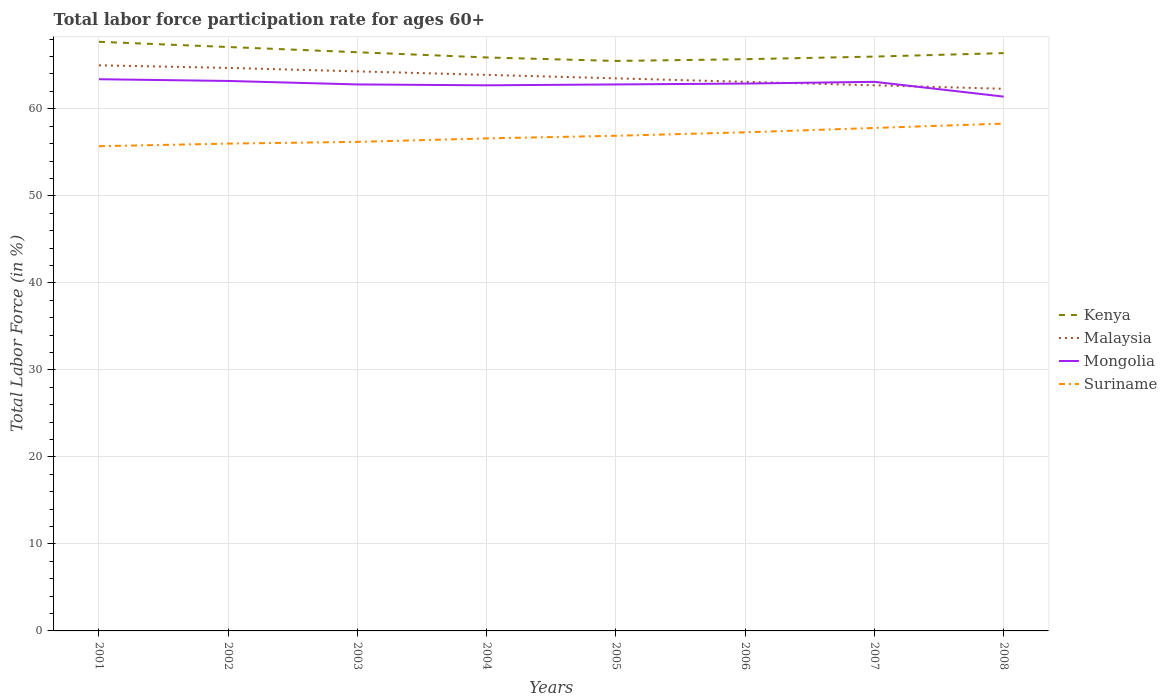Does the line corresponding to Kenya intersect with the line corresponding to Suriname?
Ensure brevity in your answer.  No. Across all years, what is the maximum labor force participation rate in Suriname?
Provide a short and direct response. 55.7. In which year was the labor force participation rate in Malaysia maximum?
Your answer should be very brief. 2008. What is the total labor force participation rate in Mongolia in the graph?
Offer a very short reply. 0.2. What is the difference between the highest and the second highest labor force participation rate in Suriname?
Offer a terse response. 2.6. How many years are there in the graph?
Your answer should be compact. 8. What is the difference between two consecutive major ticks on the Y-axis?
Make the answer very short. 10. Are the values on the major ticks of Y-axis written in scientific E-notation?
Ensure brevity in your answer.  No. Does the graph contain grids?
Your response must be concise. Yes. Where does the legend appear in the graph?
Your answer should be very brief. Center right. What is the title of the graph?
Keep it short and to the point. Total labor force participation rate for ages 60+. What is the Total Labor Force (in %) in Kenya in 2001?
Your response must be concise. 67.7. What is the Total Labor Force (in %) of Malaysia in 2001?
Give a very brief answer. 65. What is the Total Labor Force (in %) of Mongolia in 2001?
Provide a succinct answer. 63.4. What is the Total Labor Force (in %) in Suriname in 2001?
Give a very brief answer. 55.7. What is the Total Labor Force (in %) in Kenya in 2002?
Your response must be concise. 67.1. What is the Total Labor Force (in %) in Malaysia in 2002?
Offer a very short reply. 64.7. What is the Total Labor Force (in %) of Mongolia in 2002?
Keep it short and to the point. 63.2. What is the Total Labor Force (in %) of Suriname in 2002?
Your response must be concise. 56. What is the Total Labor Force (in %) of Kenya in 2003?
Your answer should be compact. 66.5. What is the Total Labor Force (in %) of Malaysia in 2003?
Make the answer very short. 64.3. What is the Total Labor Force (in %) in Mongolia in 2003?
Offer a very short reply. 62.8. What is the Total Labor Force (in %) in Suriname in 2003?
Your answer should be very brief. 56.2. What is the Total Labor Force (in %) of Kenya in 2004?
Give a very brief answer. 65.9. What is the Total Labor Force (in %) of Malaysia in 2004?
Your response must be concise. 63.9. What is the Total Labor Force (in %) in Mongolia in 2004?
Your answer should be very brief. 62.7. What is the Total Labor Force (in %) of Suriname in 2004?
Keep it short and to the point. 56.6. What is the Total Labor Force (in %) in Kenya in 2005?
Your answer should be compact. 65.5. What is the Total Labor Force (in %) in Malaysia in 2005?
Your answer should be very brief. 63.5. What is the Total Labor Force (in %) in Mongolia in 2005?
Ensure brevity in your answer.  62.8. What is the Total Labor Force (in %) in Suriname in 2005?
Provide a succinct answer. 56.9. What is the Total Labor Force (in %) in Kenya in 2006?
Give a very brief answer. 65.7. What is the Total Labor Force (in %) in Malaysia in 2006?
Your answer should be compact. 63.1. What is the Total Labor Force (in %) of Mongolia in 2006?
Your response must be concise. 62.9. What is the Total Labor Force (in %) of Suriname in 2006?
Offer a very short reply. 57.3. What is the Total Labor Force (in %) of Malaysia in 2007?
Your answer should be very brief. 62.7. What is the Total Labor Force (in %) in Mongolia in 2007?
Your answer should be compact. 63.1. What is the Total Labor Force (in %) in Suriname in 2007?
Offer a terse response. 57.8. What is the Total Labor Force (in %) of Kenya in 2008?
Ensure brevity in your answer.  66.4. What is the Total Labor Force (in %) in Malaysia in 2008?
Your answer should be compact. 62.3. What is the Total Labor Force (in %) of Mongolia in 2008?
Offer a terse response. 61.4. What is the Total Labor Force (in %) in Suriname in 2008?
Provide a short and direct response. 58.3. Across all years, what is the maximum Total Labor Force (in %) in Kenya?
Keep it short and to the point. 67.7. Across all years, what is the maximum Total Labor Force (in %) in Malaysia?
Your answer should be very brief. 65. Across all years, what is the maximum Total Labor Force (in %) of Mongolia?
Ensure brevity in your answer.  63.4. Across all years, what is the maximum Total Labor Force (in %) of Suriname?
Offer a very short reply. 58.3. Across all years, what is the minimum Total Labor Force (in %) of Kenya?
Offer a very short reply. 65.5. Across all years, what is the minimum Total Labor Force (in %) in Malaysia?
Provide a short and direct response. 62.3. Across all years, what is the minimum Total Labor Force (in %) of Mongolia?
Keep it short and to the point. 61.4. Across all years, what is the minimum Total Labor Force (in %) in Suriname?
Offer a terse response. 55.7. What is the total Total Labor Force (in %) of Kenya in the graph?
Offer a very short reply. 530.8. What is the total Total Labor Force (in %) of Malaysia in the graph?
Keep it short and to the point. 509.5. What is the total Total Labor Force (in %) of Mongolia in the graph?
Provide a succinct answer. 502.3. What is the total Total Labor Force (in %) of Suriname in the graph?
Give a very brief answer. 454.8. What is the difference between the Total Labor Force (in %) of Malaysia in 2001 and that in 2002?
Your answer should be very brief. 0.3. What is the difference between the Total Labor Force (in %) of Mongolia in 2001 and that in 2002?
Give a very brief answer. 0.2. What is the difference between the Total Labor Force (in %) of Suriname in 2001 and that in 2002?
Give a very brief answer. -0.3. What is the difference between the Total Labor Force (in %) of Kenya in 2001 and that in 2003?
Give a very brief answer. 1.2. What is the difference between the Total Labor Force (in %) in Mongolia in 2001 and that in 2003?
Provide a succinct answer. 0.6. What is the difference between the Total Labor Force (in %) in Malaysia in 2001 and that in 2004?
Keep it short and to the point. 1.1. What is the difference between the Total Labor Force (in %) in Suriname in 2001 and that in 2004?
Offer a very short reply. -0.9. What is the difference between the Total Labor Force (in %) in Kenya in 2001 and that in 2005?
Ensure brevity in your answer.  2.2. What is the difference between the Total Labor Force (in %) in Suriname in 2001 and that in 2005?
Offer a terse response. -1.2. What is the difference between the Total Labor Force (in %) in Kenya in 2001 and that in 2006?
Provide a short and direct response. 2. What is the difference between the Total Labor Force (in %) of Mongolia in 2001 and that in 2006?
Offer a very short reply. 0.5. What is the difference between the Total Labor Force (in %) of Suriname in 2001 and that in 2006?
Keep it short and to the point. -1.6. What is the difference between the Total Labor Force (in %) in Suriname in 2001 and that in 2007?
Give a very brief answer. -2.1. What is the difference between the Total Labor Force (in %) in Malaysia in 2001 and that in 2008?
Provide a succinct answer. 2.7. What is the difference between the Total Labor Force (in %) of Mongolia in 2001 and that in 2008?
Keep it short and to the point. 2. What is the difference between the Total Labor Force (in %) in Suriname in 2001 and that in 2008?
Give a very brief answer. -2.6. What is the difference between the Total Labor Force (in %) in Kenya in 2002 and that in 2003?
Provide a short and direct response. 0.6. What is the difference between the Total Labor Force (in %) in Mongolia in 2002 and that in 2003?
Provide a succinct answer. 0.4. What is the difference between the Total Labor Force (in %) of Malaysia in 2002 and that in 2004?
Your answer should be very brief. 0.8. What is the difference between the Total Labor Force (in %) in Suriname in 2002 and that in 2004?
Ensure brevity in your answer.  -0.6. What is the difference between the Total Labor Force (in %) of Kenya in 2002 and that in 2005?
Provide a succinct answer. 1.6. What is the difference between the Total Labor Force (in %) of Malaysia in 2002 and that in 2005?
Make the answer very short. 1.2. What is the difference between the Total Labor Force (in %) in Mongolia in 2002 and that in 2005?
Give a very brief answer. 0.4. What is the difference between the Total Labor Force (in %) of Suriname in 2002 and that in 2005?
Make the answer very short. -0.9. What is the difference between the Total Labor Force (in %) in Kenya in 2002 and that in 2006?
Your response must be concise. 1.4. What is the difference between the Total Labor Force (in %) of Malaysia in 2002 and that in 2007?
Give a very brief answer. 2. What is the difference between the Total Labor Force (in %) of Mongolia in 2002 and that in 2007?
Offer a terse response. 0.1. What is the difference between the Total Labor Force (in %) in Malaysia in 2002 and that in 2008?
Provide a short and direct response. 2.4. What is the difference between the Total Labor Force (in %) of Mongolia in 2002 and that in 2008?
Give a very brief answer. 1.8. What is the difference between the Total Labor Force (in %) of Malaysia in 2003 and that in 2004?
Make the answer very short. 0.4. What is the difference between the Total Labor Force (in %) of Mongolia in 2003 and that in 2004?
Your answer should be very brief. 0.1. What is the difference between the Total Labor Force (in %) in Kenya in 2003 and that in 2005?
Your answer should be compact. 1. What is the difference between the Total Labor Force (in %) in Suriname in 2003 and that in 2005?
Make the answer very short. -0.7. What is the difference between the Total Labor Force (in %) of Kenya in 2003 and that in 2006?
Keep it short and to the point. 0.8. What is the difference between the Total Labor Force (in %) of Malaysia in 2003 and that in 2006?
Your response must be concise. 1.2. What is the difference between the Total Labor Force (in %) of Mongolia in 2003 and that in 2006?
Offer a very short reply. -0.1. What is the difference between the Total Labor Force (in %) in Kenya in 2003 and that in 2007?
Provide a short and direct response. 0.5. What is the difference between the Total Labor Force (in %) in Malaysia in 2003 and that in 2007?
Your answer should be very brief. 1.6. What is the difference between the Total Labor Force (in %) in Mongolia in 2003 and that in 2007?
Offer a very short reply. -0.3. What is the difference between the Total Labor Force (in %) in Suriname in 2003 and that in 2007?
Your response must be concise. -1.6. What is the difference between the Total Labor Force (in %) in Kenya in 2003 and that in 2008?
Provide a succinct answer. 0.1. What is the difference between the Total Labor Force (in %) in Suriname in 2004 and that in 2005?
Make the answer very short. -0.3. What is the difference between the Total Labor Force (in %) of Kenya in 2004 and that in 2006?
Offer a terse response. 0.2. What is the difference between the Total Labor Force (in %) in Kenya in 2004 and that in 2007?
Ensure brevity in your answer.  -0.1. What is the difference between the Total Labor Force (in %) in Malaysia in 2004 and that in 2007?
Provide a short and direct response. 1.2. What is the difference between the Total Labor Force (in %) in Suriname in 2004 and that in 2007?
Ensure brevity in your answer.  -1.2. What is the difference between the Total Labor Force (in %) in Kenya in 2004 and that in 2008?
Your answer should be compact. -0.5. What is the difference between the Total Labor Force (in %) in Mongolia in 2004 and that in 2008?
Your answer should be compact. 1.3. What is the difference between the Total Labor Force (in %) in Suriname in 2004 and that in 2008?
Ensure brevity in your answer.  -1.7. What is the difference between the Total Labor Force (in %) of Kenya in 2005 and that in 2006?
Keep it short and to the point. -0.2. What is the difference between the Total Labor Force (in %) of Mongolia in 2005 and that in 2006?
Keep it short and to the point. -0.1. What is the difference between the Total Labor Force (in %) in Malaysia in 2005 and that in 2007?
Keep it short and to the point. 0.8. What is the difference between the Total Labor Force (in %) in Mongolia in 2005 and that in 2007?
Your answer should be very brief. -0.3. What is the difference between the Total Labor Force (in %) in Suriname in 2005 and that in 2007?
Give a very brief answer. -0.9. What is the difference between the Total Labor Force (in %) of Malaysia in 2006 and that in 2007?
Provide a succinct answer. 0.4. What is the difference between the Total Labor Force (in %) of Mongolia in 2006 and that in 2007?
Provide a short and direct response. -0.2. What is the difference between the Total Labor Force (in %) in Suriname in 2006 and that in 2007?
Your answer should be compact. -0.5. What is the difference between the Total Labor Force (in %) of Malaysia in 2006 and that in 2008?
Your response must be concise. 0.8. What is the difference between the Total Labor Force (in %) of Mongolia in 2006 and that in 2008?
Make the answer very short. 1.5. What is the difference between the Total Labor Force (in %) of Kenya in 2007 and that in 2008?
Your answer should be compact. -0.4. What is the difference between the Total Labor Force (in %) in Mongolia in 2007 and that in 2008?
Ensure brevity in your answer.  1.7. What is the difference between the Total Labor Force (in %) of Kenya in 2001 and the Total Labor Force (in %) of Malaysia in 2002?
Offer a terse response. 3. What is the difference between the Total Labor Force (in %) in Malaysia in 2001 and the Total Labor Force (in %) in Mongolia in 2002?
Your response must be concise. 1.8. What is the difference between the Total Labor Force (in %) in Mongolia in 2001 and the Total Labor Force (in %) in Suriname in 2002?
Offer a terse response. 7.4. What is the difference between the Total Labor Force (in %) of Kenya in 2001 and the Total Labor Force (in %) of Suriname in 2003?
Ensure brevity in your answer.  11.5. What is the difference between the Total Labor Force (in %) in Malaysia in 2001 and the Total Labor Force (in %) in Suriname in 2003?
Provide a short and direct response. 8.8. What is the difference between the Total Labor Force (in %) in Mongolia in 2001 and the Total Labor Force (in %) in Suriname in 2003?
Offer a very short reply. 7.2. What is the difference between the Total Labor Force (in %) of Kenya in 2001 and the Total Labor Force (in %) of Malaysia in 2004?
Keep it short and to the point. 3.8. What is the difference between the Total Labor Force (in %) of Malaysia in 2001 and the Total Labor Force (in %) of Mongolia in 2004?
Make the answer very short. 2.3. What is the difference between the Total Labor Force (in %) in Malaysia in 2001 and the Total Labor Force (in %) in Suriname in 2004?
Provide a short and direct response. 8.4. What is the difference between the Total Labor Force (in %) in Kenya in 2001 and the Total Labor Force (in %) in Malaysia in 2005?
Provide a succinct answer. 4.2. What is the difference between the Total Labor Force (in %) of Kenya in 2001 and the Total Labor Force (in %) of Malaysia in 2006?
Keep it short and to the point. 4.6. What is the difference between the Total Labor Force (in %) in Kenya in 2001 and the Total Labor Force (in %) in Mongolia in 2006?
Give a very brief answer. 4.8. What is the difference between the Total Labor Force (in %) of Malaysia in 2001 and the Total Labor Force (in %) of Mongolia in 2006?
Provide a succinct answer. 2.1. What is the difference between the Total Labor Force (in %) in Malaysia in 2001 and the Total Labor Force (in %) in Suriname in 2006?
Provide a short and direct response. 7.7. What is the difference between the Total Labor Force (in %) in Kenya in 2001 and the Total Labor Force (in %) in Malaysia in 2007?
Provide a succinct answer. 5. What is the difference between the Total Labor Force (in %) in Mongolia in 2001 and the Total Labor Force (in %) in Suriname in 2007?
Keep it short and to the point. 5.6. What is the difference between the Total Labor Force (in %) of Kenya in 2001 and the Total Labor Force (in %) of Malaysia in 2008?
Make the answer very short. 5.4. What is the difference between the Total Labor Force (in %) in Kenya in 2001 and the Total Labor Force (in %) in Mongolia in 2008?
Offer a very short reply. 6.3. What is the difference between the Total Labor Force (in %) of Malaysia in 2001 and the Total Labor Force (in %) of Suriname in 2008?
Give a very brief answer. 6.7. What is the difference between the Total Labor Force (in %) of Kenya in 2002 and the Total Labor Force (in %) of Malaysia in 2003?
Provide a short and direct response. 2.8. What is the difference between the Total Labor Force (in %) in Kenya in 2002 and the Total Labor Force (in %) in Mongolia in 2003?
Provide a short and direct response. 4.3. What is the difference between the Total Labor Force (in %) in Kenya in 2002 and the Total Labor Force (in %) in Suriname in 2003?
Provide a succinct answer. 10.9. What is the difference between the Total Labor Force (in %) of Mongolia in 2002 and the Total Labor Force (in %) of Suriname in 2003?
Offer a very short reply. 7. What is the difference between the Total Labor Force (in %) of Kenya in 2002 and the Total Labor Force (in %) of Malaysia in 2004?
Your response must be concise. 3.2. What is the difference between the Total Labor Force (in %) of Kenya in 2002 and the Total Labor Force (in %) of Mongolia in 2004?
Offer a very short reply. 4.4. What is the difference between the Total Labor Force (in %) in Malaysia in 2002 and the Total Labor Force (in %) in Suriname in 2004?
Make the answer very short. 8.1. What is the difference between the Total Labor Force (in %) of Kenya in 2002 and the Total Labor Force (in %) of Suriname in 2005?
Provide a succinct answer. 10.2. What is the difference between the Total Labor Force (in %) in Malaysia in 2002 and the Total Labor Force (in %) in Mongolia in 2005?
Ensure brevity in your answer.  1.9. What is the difference between the Total Labor Force (in %) in Malaysia in 2002 and the Total Labor Force (in %) in Suriname in 2005?
Give a very brief answer. 7.8. What is the difference between the Total Labor Force (in %) in Kenya in 2002 and the Total Labor Force (in %) in Malaysia in 2006?
Your answer should be compact. 4. What is the difference between the Total Labor Force (in %) in Kenya in 2002 and the Total Labor Force (in %) in Suriname in 2006?
Provide a succinct answer. 9.8. What is the difference between the Total Labor Force (in %) of Malaysia in 2002 and the Total Labor Force (in %) of Suriname in 2006?
Offer a terse response. 7.4. What is the difference between the Total Labor Force (in %) of Kenya in 2002 and the Total Labor Force (in %) of Malaysia in 2007?
Make the answer very short. 4.4. What is the difference between the Total Labor Force (in %) of Kenya in 2002 and the Total Labor Force (in %) of Mongolia in 2008?
Give a very brief answer. 5.7. What is the difference between the Total Labor Force (in %) in Kenya in 2002 and the Total Labor Force (in %) in Suriname in 2008?
Give a very brief answer. 8.8. What is the difference between the Total Labor Force (in %) of Malaysia in 2002 and the Total Labor Force (in %) of Suriname in 2008?
Your answer should be compact. 6.4. What is the difference between the Total Labor Force (in %) in Kenya in 2003 and the Total Labor Force (in %) in Mongolia in 2005?
Give a very brief answer. 3.7. What is the difference between the Total Labor Force (in %) in Malaysia in 2003 and the Total Labor Force (in %) in Suriname in 2005?
Offer a terse response. 7.4. What is the difference between the Total Labor Force (in %) in Mongolia in 2003 and the Total Labor Force (in %) in Suriname in 2005?
Your response must be concise. 5.9. What is the difference between the Total Labor Force (in %) of Kenya in 2003 and the Total Labor Force (in %) of Malaysia in 2006?
Your answer should be compact. 3.4. What is the difference between the Total Labor Force (in %) of Malaysia in 2003 and the Total Labor Force (in %) of Mongolia in 2007?
Offer a terse response. 1.2. What is the difference between the Total Labor Force (in %) of Mongolia in 2003 and the Total Labor Force (in %) of Suriname in 2007?
Offer a very short reply. 5. What is the difference between the Total Labor Force (in %) of Kenya in 2003 and the Total Labor Force (in %) of Malaysia in 2008?
Make the answer very short. 4.2. What is the difference between the Total Labor Force (in %) in Malaysia in 2003 and the Total Labor Force (in %) in Suriname in 2008?
Ensure brevity in your answer.  6. What is the difference between the Total Labor Force (in %) of Mongolia in 2003 and the Total Labor Force (in %) of Suriname in 2008?
Provide a short and direct response. 4.5. What is the difference between the Total Labor Force (in %) in Kenya in 2004 and the Total Labor Force (in %) in Malaysia in 2005?
Your answer should be compact. 2.4. What is the difference between the Total Labor Force (in %) in Kenya in 2004 and the Total Labor Force (in %) in Suriname in 2005?
Ensure brevity in your answer.  9. What is the difference between the Total Labor Force (in %) in Malaysia in 2004 and the Total Labor Force (in %) in Mongolia in 2005?
Your answer should be very brief. 1.1. What is the difference between the Total Labor Force (in %) in Mongolia in 2004 and the Total Labor Force (in %) in Suriname in 2005?
Keep it short and to the point. 5.8. What is the difference between the Total Labor Force (in %) in Kenya in 2004 and the Total Labor Force (in %) in Mongolia in 2006?
Offer a terse response. 3. What is the difference between the Total Labor Force (in %) in Mongolia in 2004 and the Total Labor Force (in %) in Suriname in 2006?
Provide a succinct answer. 5.4. What is the difference between the Total Labor Force (in %) in Kenya in 2004 and the Total Labor Force (in %) in Suriname in 2007?
Provide a short and direct response. 8.1. What is the difference between the Total Labor Force (in %) of Kenya in 2004 and the Total Labor Force (in %) of Mongolia in 2008?
Your response must be concise. 4.5. What is the difference between the Total Labor Force (in %) of Kenya in 2004 and the Total Labor Force (in %) of Suriname in 2008?
Your response must be concise. 7.6. What is the difference between the Total Labor Force (in %) in Malaysia in 2004 and the Total Labor Force (in %) in Mongolia in 2008?
Offer a very short reply. 2.5. What is the difference between the Total Labor Force (in %) in Kenya in 2005 and the Total Labor Force (in %) in Malaysia in 2006?
Ensure brevity in your answer.  2.4. What is the difference between the Total Labor Force (in %) in Kenya in 2005 and the Total Labor Force (in %) in Suriname in 2006?
Offer a very short reply. 8.2. What is the difference between the Total Labor Force (in %) of Malaysia in 2005 and the Total Labor Force (in %) of Suriname in 2006?
Provide a short and direct response. 6.2. What is the difference between the Total Labor Force (in %) in Kenya in 2005 and the Total Labor Force (in %) in Malaysia in 2007?
Your answer should be compact. 2.8. What is the difference between the Total Labor Force (in %) of Mongolia in 2005 and the Total Labor Force (in %) of Suriname in 2007?
Your response must be concise. 5. What is the difference between the Total Labor Force (in %) of Malaysia in 2005 and the Total Labor Force (in %) of Suriname in 2008?
Your answer should be compact. 5.2. What is the difference between the Total Labor Force (in %) in Kenya in 2006 and the Total Labor Force (in %) in Suriname in 2007?
Your response must be concise. 7.9. What is the difference between the Total Labor Force (in %) of Mongolia in 2006 and the Total Labor Force (in %) of Suriname in 2007?
Make the answer very short. 5.1. What is the difference between the Total Labor Force (in %) in Malaysia in 2006 and the Total Labor Force (in %) in Suriname in 2008?
Keep it short and to the point. 4.8. What is the difference between the Total Labor Force (in %) of Kenya in 2007 and the Total Labor Force (in %) of Mongolia in 2008?
Your answer should be compact. 4.6. What is the difference between the Total Labor Force (in %) in Kenya in 2007 and the Total Labor Force (in %) in Suriname in 2008?
Provide a succinct answer. 7.7. What is the difference between the Total Labor Force (in %) in Malaysia in 2007 and the Total Labor Force (in %) in Mongolia in 2008?
Your answer should be compact. 1.3. What is the difference between the Total Labor Force (in %) of Malaysia in 2007 and the Total Labor Force (in %) of Suriname in 2008?
Provide a succinct answer. 4.4. What is the average Total Labor Force (in %) in Kenya per year?
Offer a very short reply. 66.35. What is the average Total Labor Force (in %) in Malaysia per year?
Your answer should be compact. 63.69. What is the average Total Labor Force (in %) in Mongolia per year?
Ensure brevity in your answer.  62.79. What is the average Total Labor Force (in %) of Suriname per year?
Offer a terse response. 56.85. In the year 2001, what is the difference between the Total Labor Force (in %) in Kenya and Total Labor Force (in %) in Malaysia?
Ensure brevity in your answer.  2.7. In the year 2001, what is the difference between the Total Labor Force (in %) in Kenya and Total Labor Force (in %) in Mongolia?
Make the answer very short. 4.3. In the year 2001, what is the difference between the Total Labor Force (in %) of Mongolia and Total Labor Force (in %) of Suriname?
Keep it short and to the point. 7.7. In the year 2002, what is the difference between the Total Labor Force (in %) of Kenya and Total Labor Force (in %) of Malaysia?
Your response must be concise. 2.4. In the year 2002, what is the difference between the Total Labor Force (in %) in Kenya and Total Labor Force (in %) in Suriname?
Your response must be concise. 11.1. In the year 2003, what is the difference between the Total Labor Force (in %) of Kenya and Total Labor Force (in %) of Malaysia?
Keep it short and to the point. 2.2. In the year 2003, what is the difference between the Total Labor Force (in %) of Kenya and Total Labor Force (in %) of Mongolia?
Keep it short and to the point. 3.7. In the year 2003, what is the difference between the Total Labor Force (in %) in Malaysia and Total Labor Force (in %) in Mongolia?
Offer a very short reply. 1.5. In the year 2003, what is the difference between the Total Labor Force (in %) of Mongolia and Total Labor Force (in %) of Suriname?
Offer a very short reply. 6.6. In the year 2004, what is the difference between the Total Labor Force (in %) of Malaysia and Total Labor Force (in %) of Suriname?
Offer a very short reply. 7.3. In the year 2004, what is the difference between the Total Labor Force (in %) of Mongolia and Total Labor Force (in %) of Suriname?
Make the answer very short. 6.1. In the year 2005, what is the difference between the Total Labor Force (in %) in Kenya and Total Labor Force (in %) in Malaysia?
Give a very brief answer. 2. In the year 2005, what is the difference between the Total Labor Force (in %) in Kenya and Total Labor Force (in %) in Mongolia?
Provide a succinct answer. 2.7. In the year 2006, what is the difference between the Total Labor Force (in %) of Malaysia and Total Labor Force (in %) of Suriname?
Provide a short and direct response. 5.8. In the year 2006, what is the difference between the Total Labor Force (in %) in Mongolia and Total Labor Force (in %) in Suriname?
Offer a terse response. 5.6. In the year 2007, what is the difference between the Total Labor Force (in %) of Kenya and Total Labor Force (in %) of Malaysia?
Offer a very short reply. 3.3. In the year 2008, what is the difference between the Total Labor Force (in %) in Kenya and Total Labor Force (in %) in Malaysia?
Your response must be concise. 4.1. In the year 2008, what is the difference between the Total Labor Force (in %) in Malaysia and Total Labor Force (in %) in Suriname?
Your response must be concise. 4. In the year 2008, what is the difference between the Total Labor Force (in %) in Mongolia and Total Labor Force (in %) in Suriname?
Your answer should be very brief. 3.1. What is the ratio of the Total Labor Force (in %) in Kenya in 2001 to that in 2002?
Your answer should be compact. 1.01. What is the ratio of the Total Labor Force (in %) in Malaysia in 2001 to that in 2002?
Provide a short and direct response. 1. What is the ratio of the Total Labor Force (in %) of Kenya in 2001 to that in 2003?
Make the answer very short. 1.02. What is the ratio of the Total Labor Force (in %) in Malaysia in 2001 to that in 2003?
Provide a succinct answer. 1.01. What is the ratio of the Total Labor Force (in %) of Mongolia in 2001 to that in 2003?
Provide a succinct answer. 1.01. What is the ratio of the Total Labor Force (in %) of Suriname in 2001 to that in 2003?
Your answer should be very brief. 0.99. What is the ratio of the Total Labor Force (in %) of Kenya in 2001 to that in 2004?
Offer a terse response. 1.03. What is the ratio of the Total Labor Force (in %) in Malaysia in 2001 to that in 2004?
Ensure brevity in your answer.  1.02. What is the ratio of the Total Labor Force (in %) in Mongolia in 2001 to that in 2004?
Your answer should be very brief. 1.01. What is the ratio of the Total Labor Force (in %) in Suriname in 2001 to that in 2004?
Your response must be concise. 0.98. What is the ratio of the Total Labor Force (in %) in Kenya in 2001 to that in 2005?
Provide a short and direct response. 1.03. What is the ratio of the Total Labor Force (in %) in Malaysia in 2001 to that in 2005?
Provide a short and direct response. 1.02. What is the ratio of the Total Labor Force (in %) in Mongolia in 2001 to that in 2005?
Offer a terse response. 1.01. What is the ratio of the Total Labor Force (in %) of Suriname in 2001 to that in 2005?
Your answer should be very brief. 0.98. What is the ratio of the Total Labor Force (in %) in Kenya in 2001 to that in 2006?
Keep it short and to the point. 1.03. What is the ratio of the Total Labor Force (in %) of Malaysia in 2001 to that in 2006?
Provide a succinct answer. 1.03. What is the ratio of the Total Labor Force (in %) of Mongolia in 2001 to that in 2006?
Your answer should be very brief. 1.01. What is the ratio of the Total Labor Force (in %) in Suriname in 2001 to that in 2006?
Your answer should be very brief. 0.97. What is the ratio of the Total Labor Force (in %) of Kenya in 2001 to that in 2007?
Ensure brevity in your answer.  1.03. What is the ratio of the Total Labor Force (in %) in Malaysia in 2001 to that in 2007?
Offer a very short reply. 1.04. What is the ratio of the Total Labor Force (in %) of Mongolia in 2001 to that in 2007?
Provide a short and direct response. 1. What is the ratio of the Total Labor Force (in %) of Suriname in 2001 to that in 2007?
Your response must be concise. 0.96. What is the ratio of the Total Labor Force (in %) in Kenya in 2001 to that in 2008?
Give a very brief answer. 1.02. What is the ratio of the Total Labor Force (in %) in Malaysia in 2001 to that in 2008?
Your answer should be compact. 1.04. What is the ratio of the Total Labor Force (in %) of Mongolia in 2001 to that in 2008?
Your answer should be compact. 1.03. What is the ratio of the Total Labor Force (in %) in Suriname in 2001 to that in 2008?
Make the answer very short. 0.96. What is the ratio of the Total Labor Force (in %) in Mongolia in 2002 to that in 2003?
Provide a short and direct response. 1.01. What is the ratio of the Total Labor Force (in %) of Suriname in 2002 to that in 2003?
Offer a terse response. 1. What is the ratio of the Total Labor Force (in %) in Kenya in 2002 to that in 2004?
Provide a short and direct response. 1.02. What is the ratio of the Total Labor Force (in %) of Malaysia in 2002 to that in 2004?
Provide a succinct answer. 1.01. What is the ratio of the Total Labor Force (in %) in Suriname in 2002 to that in 2004?
Keep it short and to the point. 0.99. What is the ratio of the Total Labor Force (in %) in Kenya in 2002 to that in 2005?
Keep it short and to the point. 1.02. What is the ratio of the Total Labor Force (in %) in Malaysia in 2002 to that in 2005?
Ensure brevity in your answer.  1.02. What is the ratio of the Total Labor Force (in %) of Mongolia in 2002 to that in 2005?
Your answer should be very brief. 1.01. What is the ratio of the Total Labor Force (in %) of Suriname in 2002 to that in 2005?
Give a very brief answer. 0.98. What is the ratio of the Total Labor Force (in %) of Kenya in 2002 to that in 2006?
Your answer should be very brief. 1.02. What is the ratio of the Total Labor Force (in %) in Malaysia in 2002 to that in 2006?
Give a very brief answer. 1.03. What is the ratio of the Total Labor Force (in %) in Suriname in 2002 to that in 2006?
Make the answer very short. 0.98. What is the ratio of the Total Labor Force (in %) in Kenya in 2002 to that in 2007?
Offer a terse response. 1.02. What is the ratio of the Total Labor Force (in %) in Malaysia in 2002 to that in 2007?
Give a very brief answer. 1.03. What is the ratio of the Total Labor Force (in %) of Mongolia in 2002 to that in 2007?
Provide a succinct answer. 1. What is the ratio of the Total Labor Force (in %) in Suriname in 2002 to that in 2007?
Provide a short and direct response. 0.97. What is the ratio of the Total Labor Force (in %) in Kenya in 2002 to that in 2008?
Keep it short and to the point. 1.01. What is the ratio of the Total Labor Force (in %) in Mongolia in 2002 to that in 2008?
Give a very brief answer. 1.03. What is the ratio of the Total Labor Force (in %) of Suriname in 2002 to that in 2008?
Provide a succinct answer. 0.96. What is the ratio of the Total Labor Force (in %) of Kenya in 2003 to that in 2004?
Provide a succinct answer. 1.01. What is the ratio of the Total Labor Force (in %) of Kenya in 2003 to that in 2005?
Your answer should be compact. 1.02. What is the ratio of the Total Labor Force (in %) of Malaysia in 2003 to that in 2005?
Your answer should be very brief. 1.01. What is the ratio of the Total Labor Force (in %) in Mongolia in 2003 to that in 2005?
Give a very brief answer. 1. What is the ratio of the Total Labor Force (in %) of Suriname in 2003 to that in 2005?
Make the answer very short. 0.99. What is the ratio of the Total Labor Force (in %) of Kenya in 2003 to that in 2006?
Provide a succinct answer. 1.01. What is the ratio of the Total Labor Force (in %) of Malaysia in 2003 to that in 2006?
Ensure brevity in your answer.  1.02. What is the ratio of the Total Labor Force (in %) in Suriname in 2003 to that in 2006?
Give a very brief answer. 0.98. What is the ratio of the Total Labor Force (in %) in Kenya in 2003 to that in 2007?
Offer a very short reply. 1.01. What is the ratio of the Total Labor Force (in %) of Malaysia in 2003 to that in 2007?
Your response must be concise. 1.03. What is the ratio of the Total Labor Force (in %) in Suriname in 2003 to that in 2007?
Offer a terse response. 0.97. What is the ratio of the Total Labor Force (in %) in Malaysia in 2003 to that in 2008?
Your response must be concise. 1.03. What is the ratio of the Total Labor Force (in %) in Mongolia in 2003 to that in 2008?
Offer a very short reply. 1.02. What is the ratio of the Total Labor Force (in %) of Suriname in 2003 to that in 2008?
Provide a short and direct response. 0.96. What is the ratio of the Total Labor Force (in %) in Kenya in 2004 to that in 2005?
Offer a terse response. 1.01. What is the ratio of the Total Labor Force (in %) of Malaysia in 2004 to that in 2005?
Your response must be concise. 1.01. What is the ratio of the Total Labor Force (in %) of Suriname in 2004 to that in 2005?
Your answer should be compact. 0.99. What is the ratio of the Total Labor Force (in %) in Malaysia in 2004 to that in 2006?
Offer a terse response. 1.01. What is the ratio of the Total Labor Force (in %) of Mongolia in 2004 to that in 2006?
Give a very brief answer. 1. What is the ratio of the Total Labor Force (in %) of Kenya in 2004 to that in 2007?
Provide a short and direct response. 1. What is the ratio of the Total Labor Force (in %) in Malaysia in 2004 to that in 2007?
Make the answer very short. 1.02. What is the ratio of the Total Labor Force (in %) of Suriname in 2004 to that in 2007?
Your response must be concise. 0.98. What is the ratio of the Total Labor Force (in %) in Malaysia in 2004 to that in 2008?
Your answer should be very brief. 1.03. What is the ratio of the Total Labor Force (in %) of Mongolia in 2004 to that in 2008?
Your answer should be compact. 1.02. What is the ratio of the Total Labor Force (in %) of Suriname in 2004 to that in 2008?
Provide a short and direct response. 0.97. What is the ratio of the Total Labor Force (in %) of Kenya in 2005 to that in 2006?
Ensure brevity in your answer.  1. What is the ratio of the Total Labor Force (in %) in Malaysia in 2005 to that in 2006?
Offer a terse response. 1.01. What is the ratio of the Total Labor Force (in %) in Mongolia in 2005 to that in 2006?
Offer a terse response. 1. What is the ratio of the Total Labor Force (in %) of Suriname in 2005 to that in 2006?
Provide a succinct answer. 0.99. What is the ratio of the Total Labor Force (in %) of Malaysia in 2005 to that in 2007?
Ensure brevity in your answer.  1.01. What is the ratio of the Total Labor Force (in %) in Mongolia in 2005 to that in 2007?
Give a very brief answer. 1. What is the ratio of the Total Labor Force (in %) of Suriname in 2005 to that in 2007?
Ensure brevity in your answer.  0.98. What is the ratio of the Total Labor Force (in %) of Kenya in 2005 to that in 2008?
Your response must be concise. 0.99. What is the ratio of the Total Labor Force (in %) of Malaysia in 2005 to that in 2008?
Your answer should be compact. 1.02. What is the ratio of the Total Labor Force (in %) in Mongolia in 2005 to that in 2008?
Your answer should be very brief. 1.02. What is the ratio of the Total Labor Force (in %) of Malaysia in 2006 to that in 2007?
Keep it short and to the point. 1.01. What is the ratio of the Total Labor Force (in %) of Kenya in 2006 to that in 2008?
Provide a short and direct response. 0.99. What is the ratio of the Total Labor Force (in %) of Malaysia in 2006 to that in 2008?
Give a very brief answer. 1.01. What is the ratio of the Total Labor Force (in %) in Mongolia in 2006 to that in 2008?
Provide a succinct answer. 1.02. What is the ratio of the Total Labor Force (in %) in Suriname in 2006 to that in 2008?
Offer a very short reply. 0.98. What is the ratio of the Total Labor Force (in %) in Kenya in 2007 to that in 2008?
Keep it short and to the point. 0.99. What is the ratio of the Total Labor Force (in %) in Malaysia in 2007 to that in 2008?
Ensure brevity in your answer.  1.01. What is the ratio of the Total Labor Force (in %) of Mongolia in 2007 to that in 2008?
Your response must be concise. 1.03. What is the difference between the highest and the second highest Total Labor Force (in %) of Kenya?
Offer a terse response. 0.6. What is the difference between the highest and the second highest Total Labor Force (in %) in Mongolia?
Make the answer very short. 0.2. What is the difference between the highest and the second highest Total Labor Force (in %) of Suriname?
Your response must be concise. 0.5. 